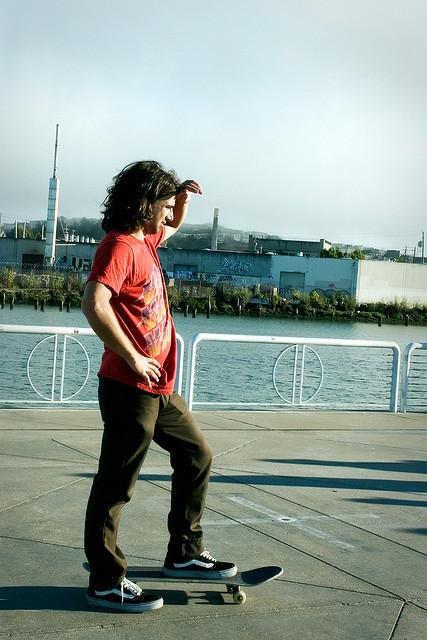What is on his wrist?
Be succinct. Nothing. What is the person standing on?
Give a very brief answer. Skateboard. What color is the man's shirt?
Be succinct. Red. What color are the wheels on the black and white skateboard?
Be succinct. White. Is that a river?
Quick response, please. Yes. 